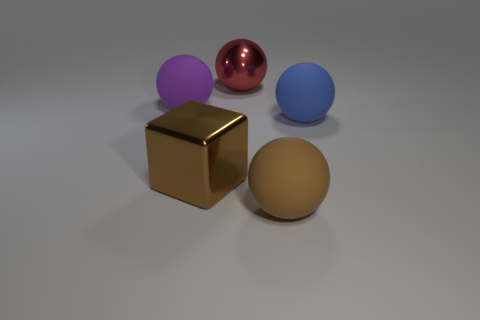Subtract all large matte balls. How many balls are left? 1 Add 2 large brown cubes. How many objects exist? 7 Subtract all red balls. How many balls are left? 3 Subtract all green spheres. Subtract all purple cubes. How many spheres are left? 4 Subtract all spheres. How many objects are left? 1 Subtract all blue objects. Subtract all large blue things. How many objects are left? 3 Add 3 big blue rubber balls. How many big blue rubber balls are left? 4 Add 5 small blue matte blocks. How many small blue matte blocks exist? 5 Subtract 0 brown cylinders. How many objects are left? 5 